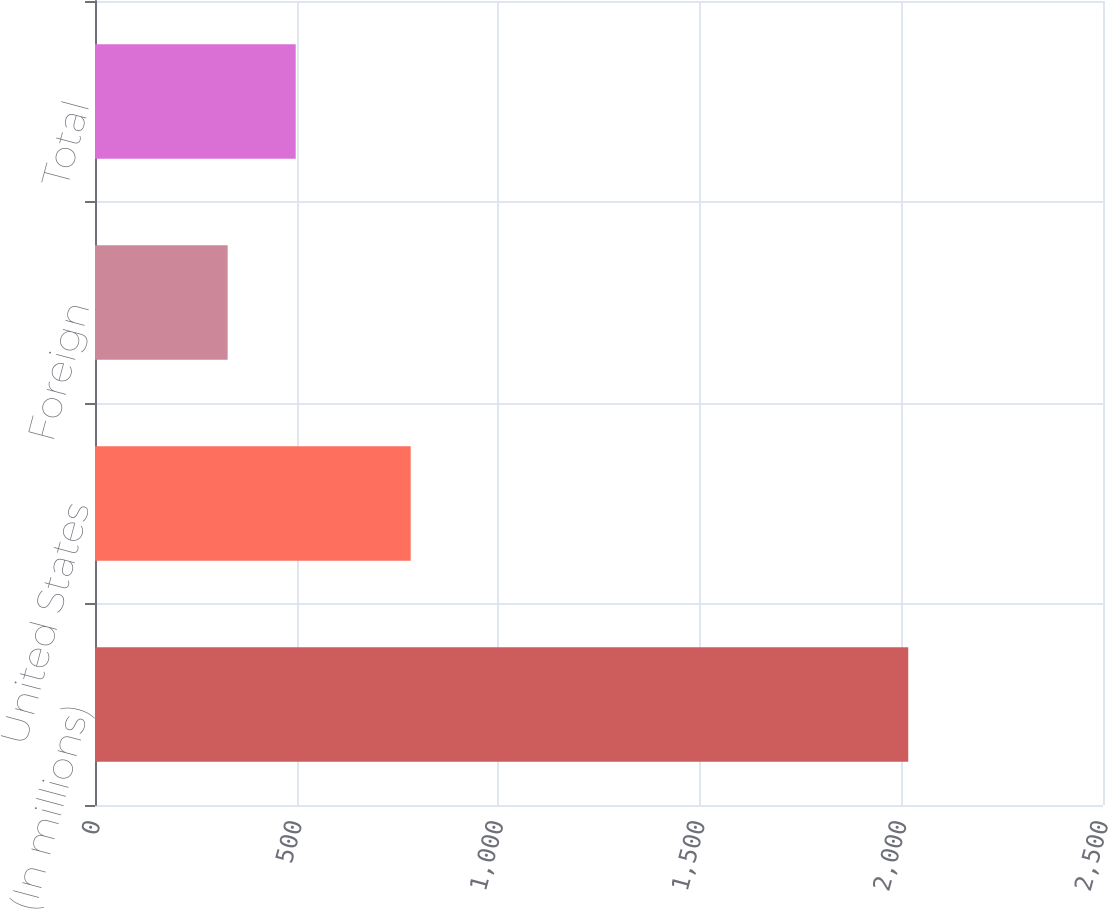Convert chart to OTSL. <chart><loc_0><loc_0><loc_500><loc_500><bar_chart><fcel>(In millions)<fcel>United States<fcel>Foreign<fcel>Total<nl><fcel>2017<fcel>783<fcel>329<fcel>497.8<nl></chart> 